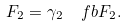<formula> <loc_0><loc_0><loc_500><loc_500>F _ { 2 } = \gamma _ { 2 } \ \ f b { F } _ { 2 } .</formula> 